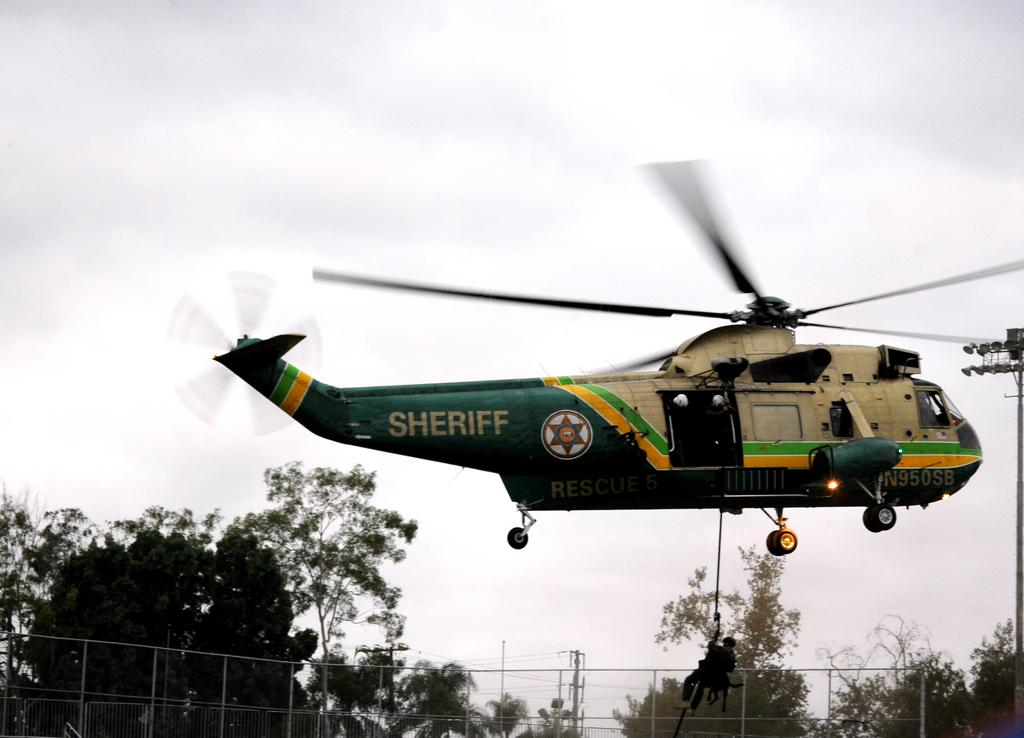Provide a one-sentence caption for the provided image. The sheriff's helicopter is flying to rescue people from a storm. 